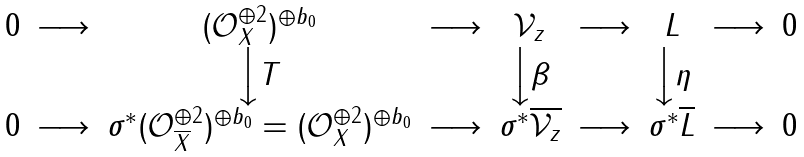<formula> <loc_0><loc_0><loc_500><loc_500>\begin{matrix} 0 & \longrightarrow & ( { \mathcal { O } } ^ { \oplus 2 } _ { X } ) ^ { \oplus b _ { 0 } } & \longrightarrow & { \mathcal { V } } _ { z } & \longrightarrow & L & \longrightarrow & 0 \\ & & \Big \downarrow { T } & & \Big \downarrow \beta & & \Big \downarrow \eta \\ 0 & \longrightarrow & \sigma ^ { * } ( { \mathcal { O } } ^ { \oplus 2 } _ { \overline { X } } ) ^ { \oplus b _ { 0 } } = ( { \mathcal { O } } ^ { \oplus 2 } _ { X } ) ^ { \oplus b _ { 0 } } & \longrightarrow & \sigma ^ { * } \overline { { \mathcal { V } } _ { z } } & \longrightarrow & \sigma ^ { * } \overline { L } & \longrightarrow & 0 \end{matrix}</formula> 